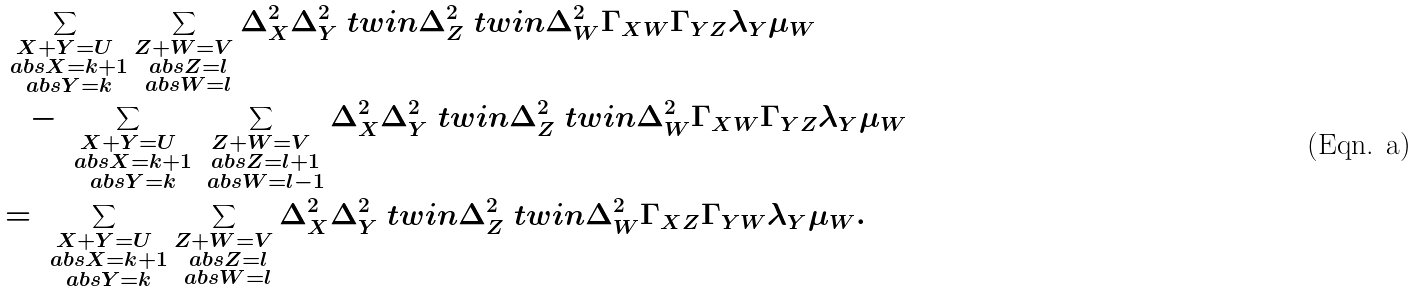<formula> <loc_0><loc_0><loc_500><loc_500>& \sum _ { \substack { X + Y = U \\ \ a b s { X } = k + 1 \\ \ a b s { Y } = k } } \sum _ { \substack { Z + W = V \\ \ a b s { Z } = l \\ \ a b s { W } = l } } \Delta _ { X } ^ { 2 } \Delta _ { Y } ^ { 2 } \ t w i n \Delta _ { Z } ^ { 2 } \ t w i n \Delta _ { W } ^ { 2 } \Gamma _ { X W } \Gamma _ { Y Z } \lambda _ { Y } \mu _ { W } \\ & \quad - \sum _ { \substack { X + Y = U \\ \ a b s { X } = k + 1 \\ \ a b s { Y } = k } } \sum _ { \substack { Z + W = V \\ \ a b s { Z } = l + 1 \\ \ a b s { W } = l - 1 } } \Delta _ { X } ^ { 2 } \Delta _ { Y } ^ { 2 } \ t w i n \Delta _ { Z } ^ { 2 } \ t w i n \Delta _ { W } ^ { 2 } \Gamma _ { X W } \Gamma _ { Y Z } \lambda _ { Y } \mu _ { W } \\ & = \sum _ { \substack { X + Y = U \\ \ a b s { X } = k + 1 \\ \ a b s { Y } = k } } \sum _ { \substack { Z + W = V \\ \ a b s { Z } = l \\ \ a b s { W } = l } } \Delta _ { X } ^ { 2 } \Delta _ { Y } ^ { 2 } \ t w i n \Delta _ { Z } ^ { 2 } \ t w i n \Delta _ { W } ^ { 2 } \Gamma _ { X Z } \Gamma _ { Y W } \lambda _ { Y } \mu _ { W } .</formula> 